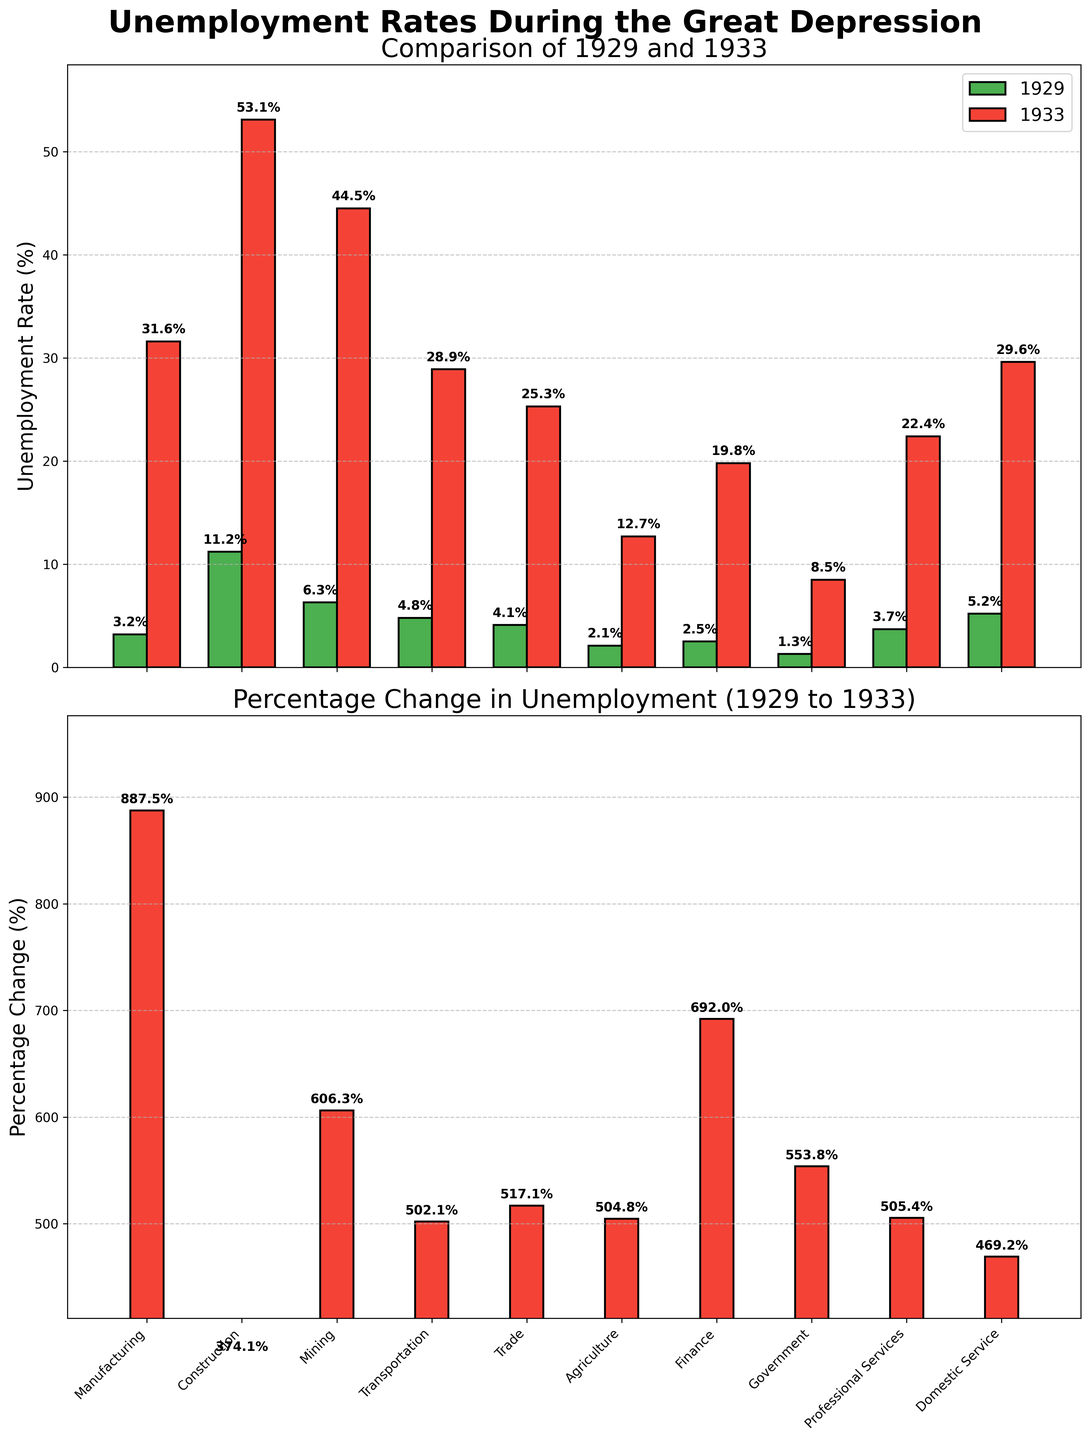What industries had the highest and lowest unemployment rates in 1929? To find the highest and lowest unemployment rates in 1929, look at the green bars in the first subplot. The highest rate is in Construction (11.2%), and the lowest rate is in Government (1.3%).
Answer: Construction, Government How much did the unemployment rate in Mining change from 1929 to 1933? The unemployment rate in Mining is shown as 6.3% in 1929 and 44.5% in 1933 in the first subplot. The change is calculated as 44.5% - 6.3% = 38.2%.
Answer: 38.2% Which industry had the largest percentage increase in unemployment rate from 1929 to 1933? The second subplot shows the percentage change in unemployment rates. The tallest red bar indicates Construction had the largest increase. The label on the top of this bar reads 374.1%.
Answer: Construction What was the average unemployment rate across all industries in 1929? Sum the unemployment rates for all industries in 1929: (3.2 + 11.2 + 6.3 + 4.8 + 4.1 + 2.1 + 2.5 + 1.3 + 3.7 + 5.2). The total is 44.4%. There are 10 industries, so the average rate is 44.4 / 10 = 4.44%.
Answer: 4.44% Compare the unemployment rates in Agriculture and Trade in 1933. Which was higher and by how much? In 1933, Agriculture had 12.7% and Trade had 25.3%. Trade is higher. Calculate the difference: 25.3% - 12.7% = 12.6%.
Answer: Trade, by 12.6% Which industry saw the smallest absolute change in unemployment rates from 1929 to 1933? Calculate the absolute change for each industry by subtracting the 1929 rate from the 1933 rate and take the absolute value. Government shows the smallest change: 8.5% - 1.3% = 7.2%.
Answer: Government By how much did the unemployment rate in Professional Services increase from 1929 to 1933? Look at the first subplot. The rate in 1929 was 3.7%, and in 1933 it was 22.4%. The increase is 22.4% - 3.7% = 18.7%.
Answer: 18.7% Which industries had an unemployment rate greater than 25% in 1933? In 1933, the red bars in the first subplot show that Manufacturing (31.6%), Construction (53.1%), Mining (44.5%), Transportation (28.9%), Trade (25.3%), and Domestic Service (29.6%) all had rates greater than 25%.
Answer: Manufacturing, Construction, Mining, Transportation, Trade, Domestic Service What is the total percentage change in unemployment rate for Manufacturing and Construction industries from 1929 to 1933? Calculate the percentage changes individually for both industries using the values from the second subplot. Manufacturing's percentage change is ((31.6 - 3.2) / 3.2) * 100 = 887.5%. Construction's percentage change is ((53.1 - 11.2) / 11.2) * 100 = 374.1%. The total percentage change is 887.5% + 374.1% = 1261.6%.
Answer: 1261.6% Which industry had the lowest percentage increase in unemployment rate from 1929 to 1933, and what was the change? According to the second subplot, Government had the lowest percentage increase, indicated by the smallest red bar and labeled as 553.8%.
Answer: Government, 553.8% 